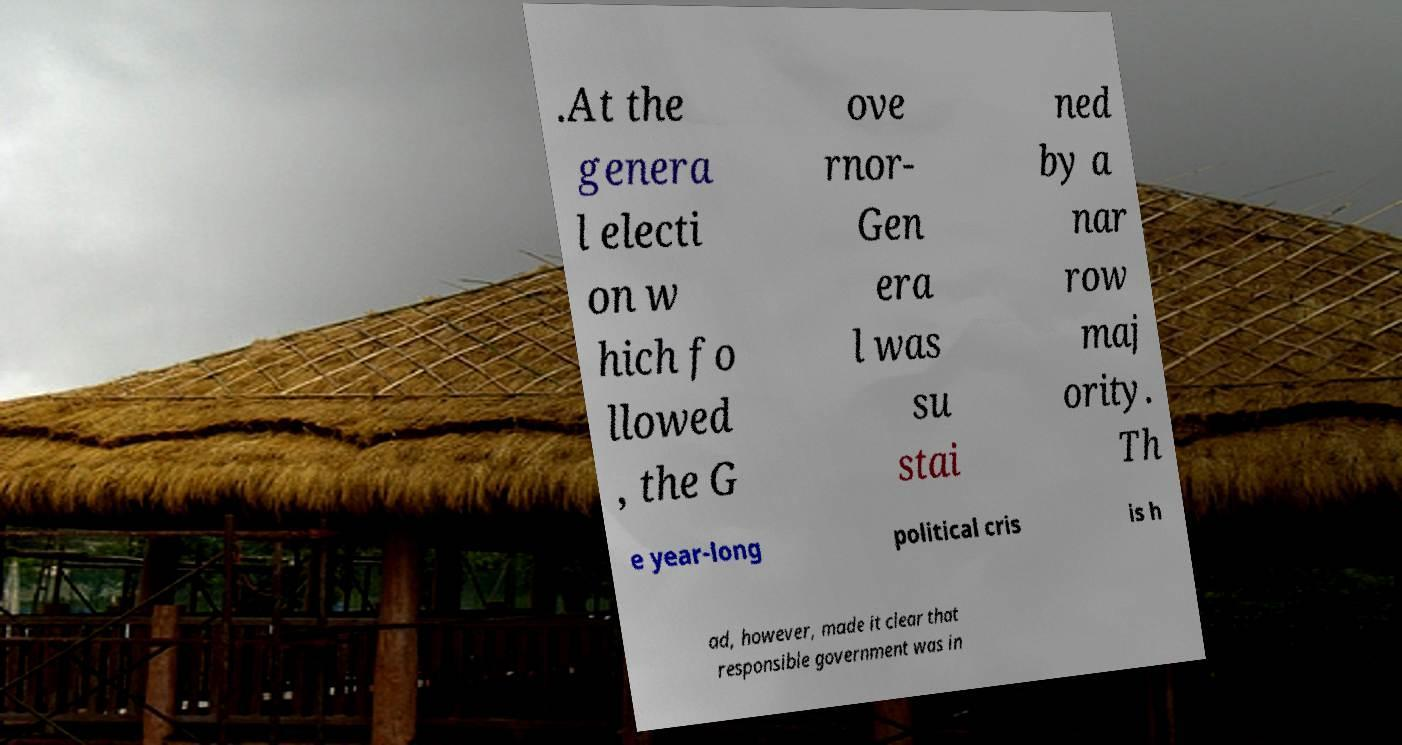Please identify and transcribe the text found in this image. .At the genera l electi on w hich fo llowed , the G ove rnor- Gen era l was su stai ned by a nar row maj ority. Th e year-long political cris is h ad, however, made it clear that responsible government was in 